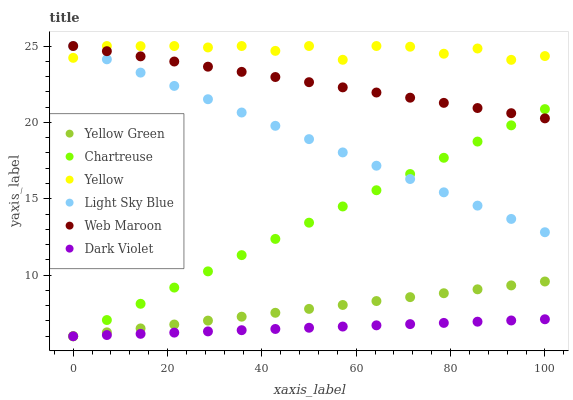Does Dark Violet have the minimum area under the curve?
Answer yes or no. Yes. Does Yellow have the maximum area under the curve?
Answer yes or no. Yes. Does Web Maroon have the minimum area under the curve?
Answer yes or no. No. Does Web Maroon have the maximum area under the curve?
Answer yes or no. No. Is Dark Violet the smoothest?
Answer yes or no. Yes. Is Yellow the roughest?
Answer yes or no. Yes. Is Web Maroon the smoothest?
Answer yes or no. No. Is Web Maroon the roughest?
Answer yes or no. No. Does Yellow Green have the lowest value?
Answer yes or no. Yes. Does Web Maroon have the lowest value?
Answer yes or no. No. Does Yellow have the highest value?
Answer yes or no. Yes. Does Dark Violet have the highest value?
Answer yes or no. No. Is Dark Violet less than Web Maroon?
Answer yes or no. Yes. Is Yellow greater than Dark Violet?
Answer yes or no. Yes. Does Light Sky Blue intersect Web Maroon?
Answer yes or no. Yes. Is Light Sky Blue less than Web Maroon?
Answer yes or no. No. Is Light Sky Blue greater than Web Maroon?
Answer yes or no. No. Does Dark Violet intersect Web Maroon?
Answer yes or no. No. 